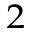Convert formula to latex. <formula><loc_0><loc_0><loc_500><loc_500>_ { 2 }</formula> 